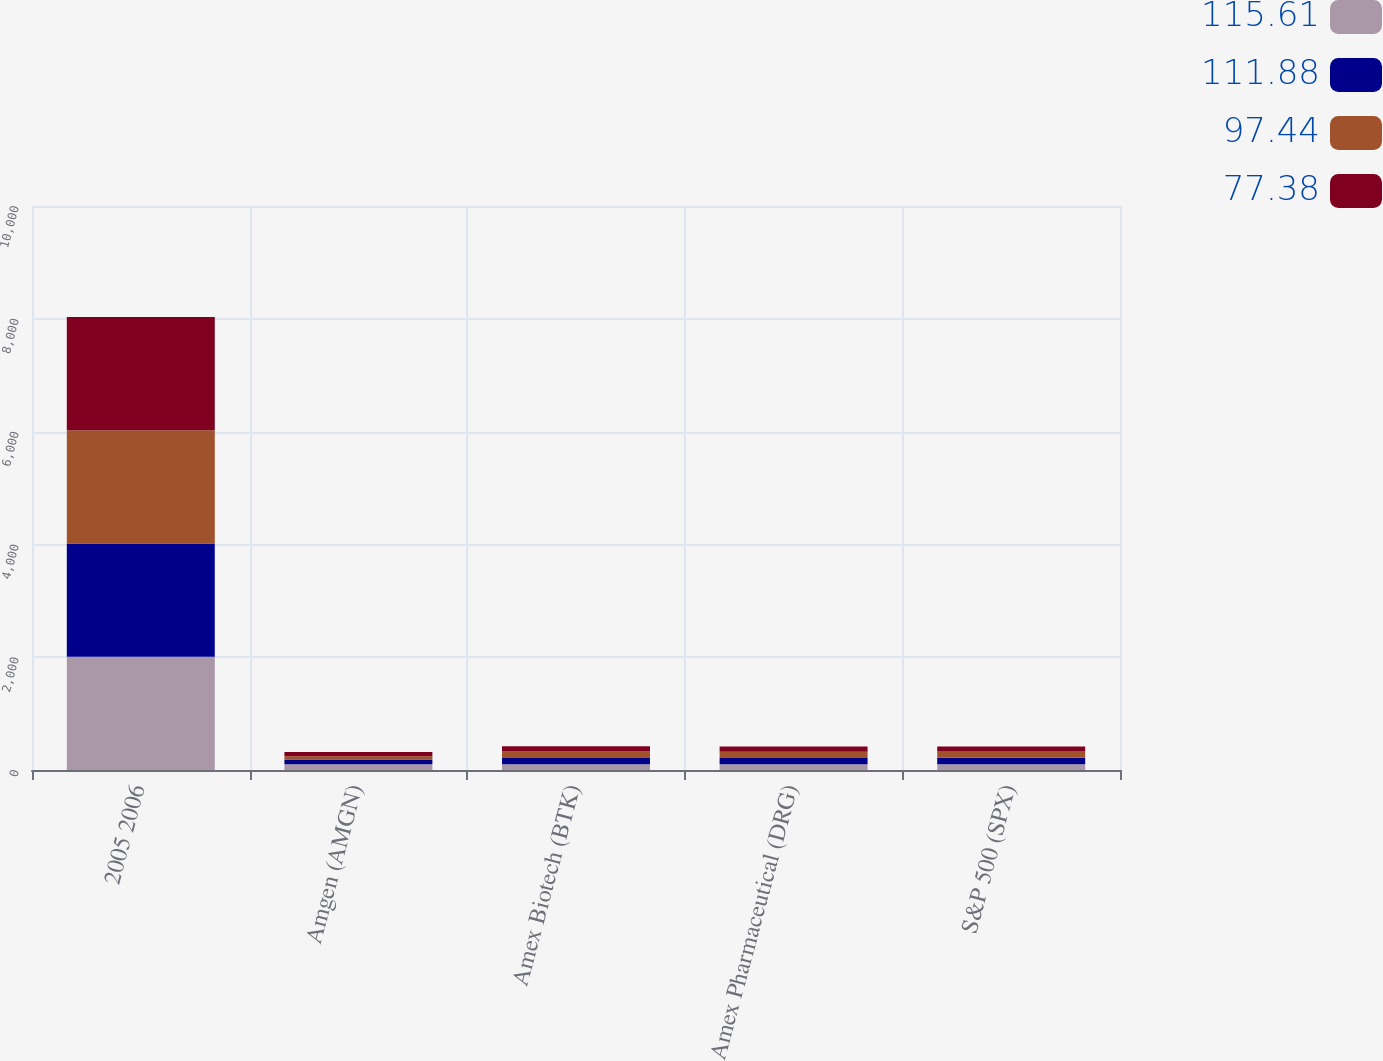<chart> <loc_0><loc_0><loc_500><loc_500><stacked_bar_chart><ecel><fcel>2005 2006<fcel>Amgen (AMGN)<fcel>Amex Biotech (BTK)<fcel>Amex Pharmaceutical (DRG)<fcel>S&P 500 (SPX)<nl><fcel>115.61<fcel>2007<fcel>100<fcel>100<fcel>100<fcel>100<nl><fcel>111.88<fcel>2008<fcel>86.62<fcel>110.77<fcel>110.59<fcel>115.61<nl><fcel>97.44<fcel>2008<fcel>58.89<fcel>115.51<fcel>111.71<fcel>121.95<nl><fcel>77.38<fcel>2009<fcel>73.23<fcel>95.05<fcel>93.74<fcel>77.38<nl></chart> 